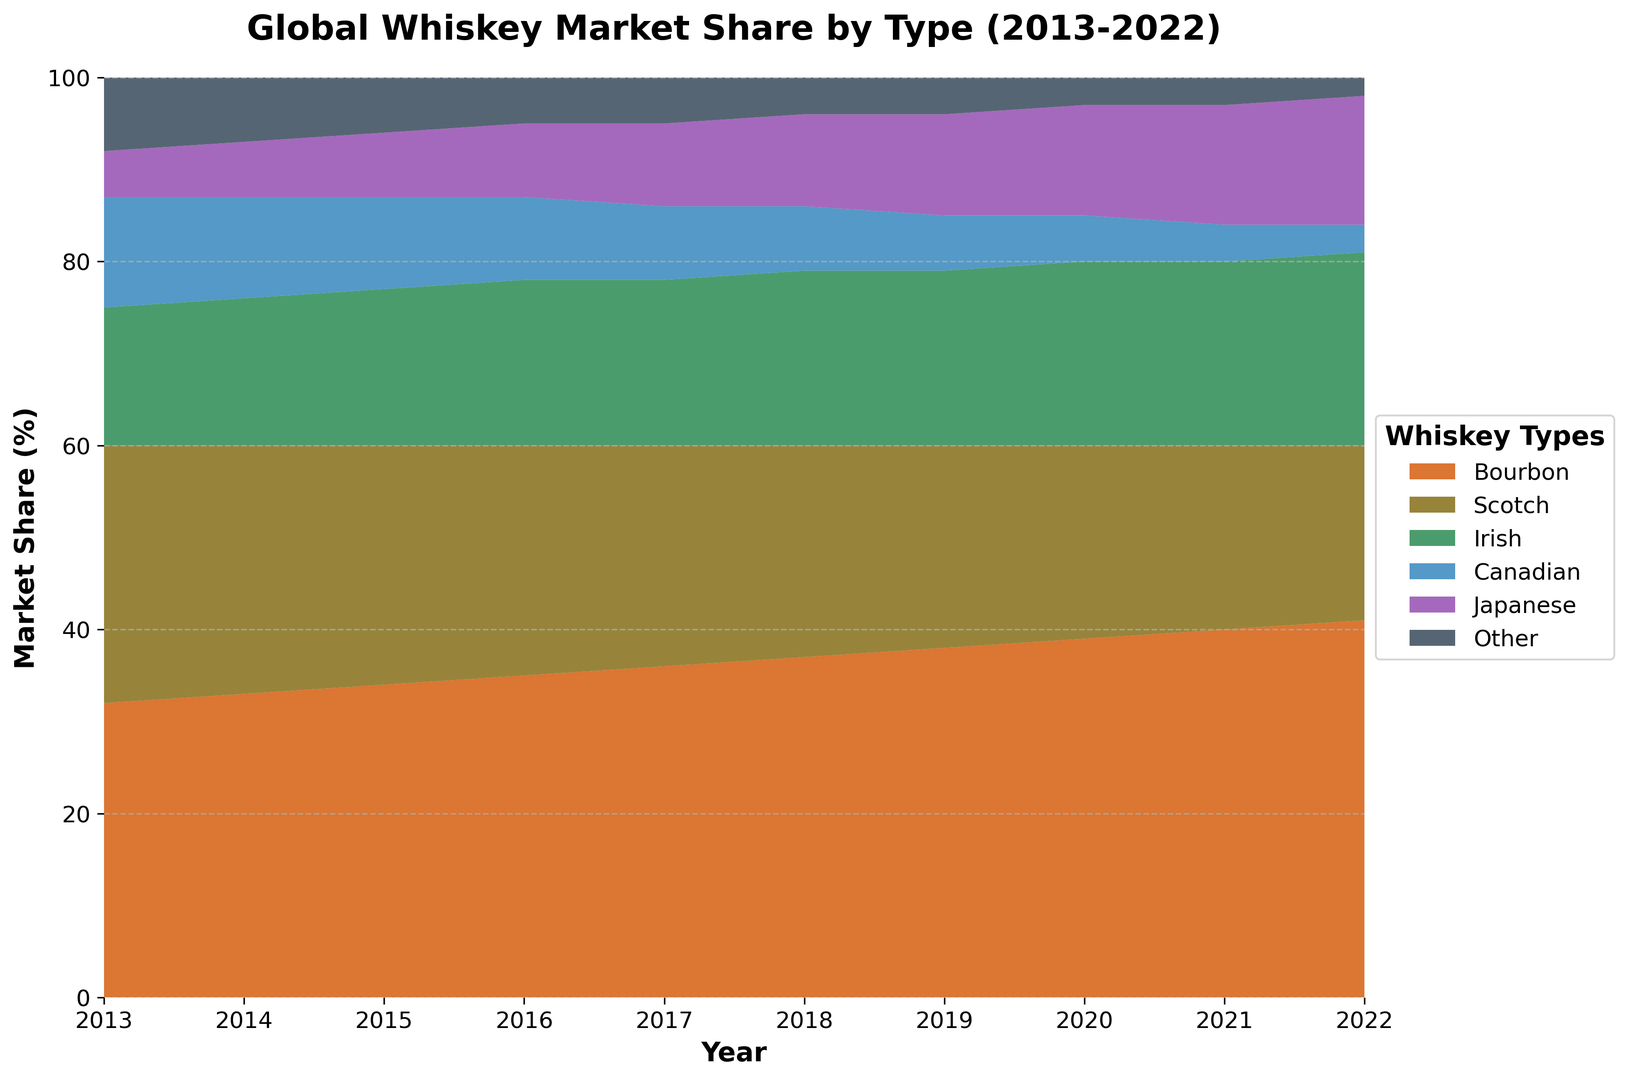What's the overall trend for Bourbon from 2013 to 2022? The market share of Bourbon shows a steady upward trend over the years. It starts at 32% in 2013 and increases by approximately 1% each year to reach 41% in 2022.
Answer: Steady upward trend Which whiskey type had the largest market share in 2022? In 2022, Bourbon had the largest market share among all whiskey types, with 41%.
Answer: Bourbon Between 2013 and 2022, which whiskey type saw the greatest decrease in market share? By observing the area covered by each whiskey, Scotch shows the greatest decrease. In 2013, it was at 28% and decreases each year to reach 19% in 2022, which is a total decrease of 9%.
Answer: Scotch When did the market share of Irish whiskey become equal to or surpass that of Scotch for the first time? Irish whiskey's market share becomes equal to Scotch in 2021 and surpasses it in 2022.
Answer: 2021 How does the market share of Japanese whiskey change from 2013 to 2022? Japanese whiskey shows a continuous increase over the years, starting at 5% in 2013 and rising steadily to reach 14% in 2022.
Answer: Continuous increase By how much did Canadian whiskey's market share drop from 2013 to 2022? The market share of Canadian whiskey drops from 12% in 2013 to 3% in 2022. The difference is 12 - 3 = 9%.
Answer: 9% Which two types of whiskey had the smallest combined market share in any year? In 2022, Canadian and Other whiskeys had the smallest combined market share, with Canadian at 3% and Other at 2%, totaling to 5%.
Answer: Canadian and Other in 2022 Which whiskey type holds the second-largest share in 2018? In 2018, Scotch holds the second-largest share with 23%, right after Bourbon with 37%.
Answer: Scotch What is the combined market share of Irish and Japanese whiskey in 2020? In 2020, Irish whiskey has a 20% share and Japanese whiskey has a 12% share. Combined, this is 20 + 12 = 32%.
Answer: 32% Are there any whiskey types with a declining trend over the entire decade? The chart shows that Scotch and Canadian whiskeys have a continuous declining trend from 2013 to 2022. Scotch drops from 28% to 19%, and Canadian drops from 12% to 3%.
Answer: Scotch and Canadian 